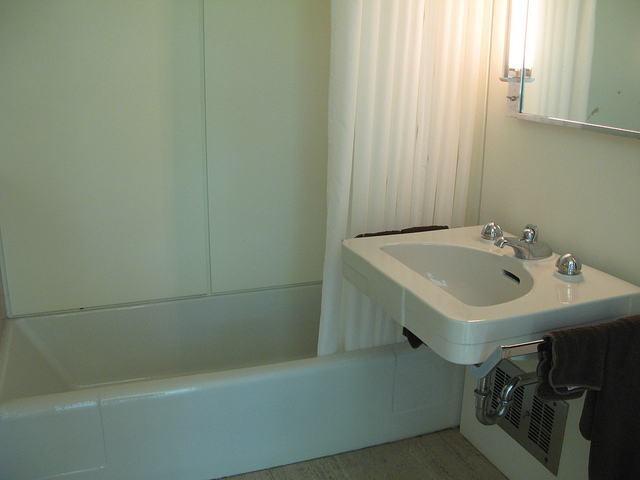<image>What color are the towel and washcloth? I don't know what color the towel and washcloth are. They could be brown, black or gray. What color are the towel and washcloth? I don't know the color of the towel and washcloth. It can be black, brown or gray. 